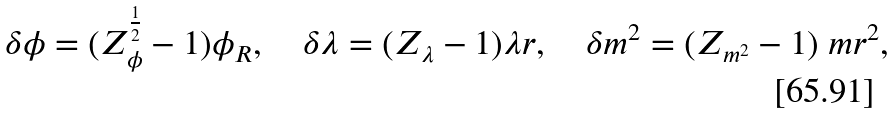Convert formula to latex. <formula><loc_0><loc_0><loc_500><loc_500>\delta \phi = ( Z _ { \phi } ^ { \frac { 1 } { 2 } } - 1 ) \phi _ { R } , \quad \delta \lambda = ( Z _ { \lambda } - 1 ) \lambda r , \quad \delta m ^ { 2 } = ( Z _ { m ^ { 2 } } - 1 ) \ m r ^ { 2 } ,</formula> 